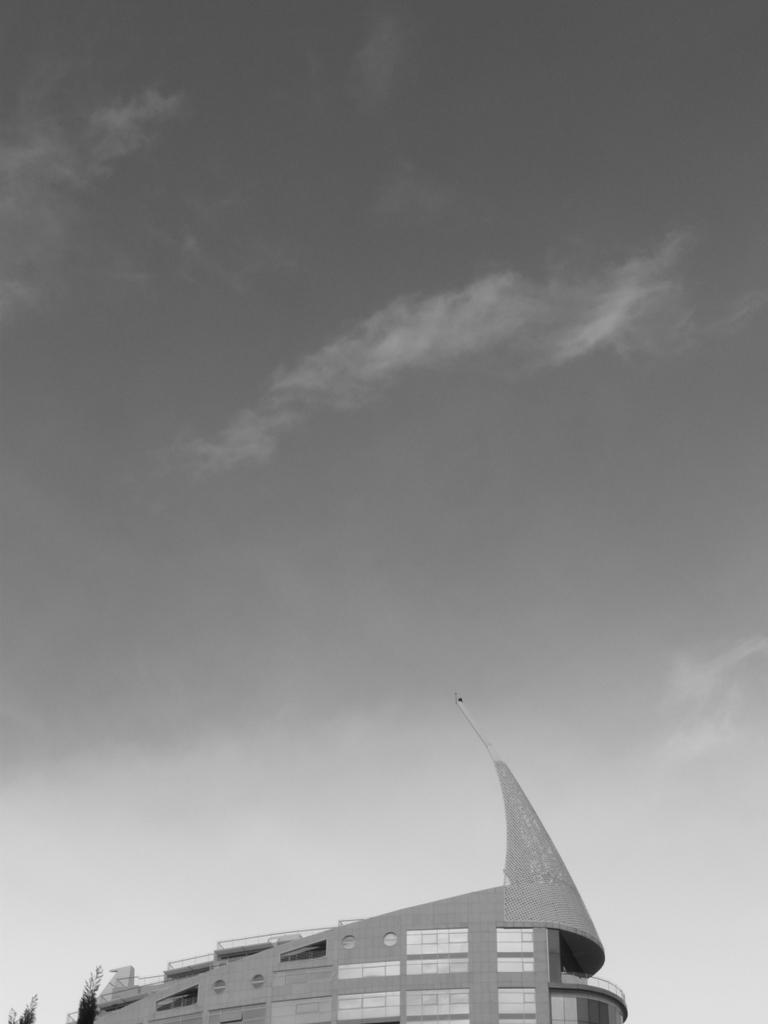What type of structure is visible in the picture? There is a building in the picture. What other natural elements can be seen in the picture? There are trees in the picture. What is visible at the top of the picture? The sky is visible at the top of the picture. What can be observed in the sky? Clouds are present in the sky. Where can the honey be found in the picture? There is no honey present in the picture. What type of sticks are visible in the picture? There are no sticks visible in the picture. 